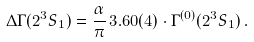Convert formula to latex. <formula><loc_0><loc_0><loc_500><loc_500>\Delta \Gamma ( 2 ^ { 3 } S _ { 1 } ) = \frac { \alpha } { \pi } \, 3 . 6 0 ( 4 ) \cdot \Gamma ^ { ( 0 ) } ( 2 ^ { 3 } S _ { 1 } ) \, .</formula> 